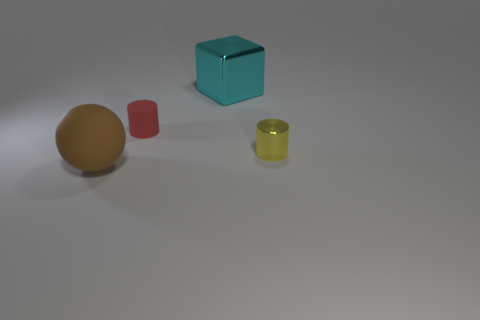There is a matte thing behind the metallic cylinder; does it have the same size as the cylinder that is on the right side of the large cyan metal cube?
Your answer should be compact. Yes. Are there the same number of cyan metal objects in front of the large cyan cube and big blocks in front of the red matte thing?
Make the answer very short. Yes. Do the red object and the metallic object that is in front of the cyan cube have the same size?
Provide a succinct answer. Yes. Is there a cylinder on the right side of the thing that is right of the cyan object?
Your answer should be compact. No. Is there another small rubber object of the same shape as the brown rubber thing?
Offer a very short reply. No. How many large blocks are behind the cylinder behind the small cylinder that is in front of the red cylinder?
Provide a short and direct response. 1. How many things are tiny cylinders to the right of the small red matte cylinder or objects that are left of the tiny yellow shiny thing?
Ensure brevity in your answer.  4. Are there more big cyan things behind the big block than cyan objects in front of the yellow metal thing?
Provide a succinct answer. No. What material is the tiny cylinder on the left side of the small object that is in front of the matte object to the right of the large matte object?
Give a very brief answer. Rubber. Is the shape of the small thing left of the tiny yellow cylinder the same as the small object that is on the right side of the red rubber cylinder?
Offer a terse response. Yes. 